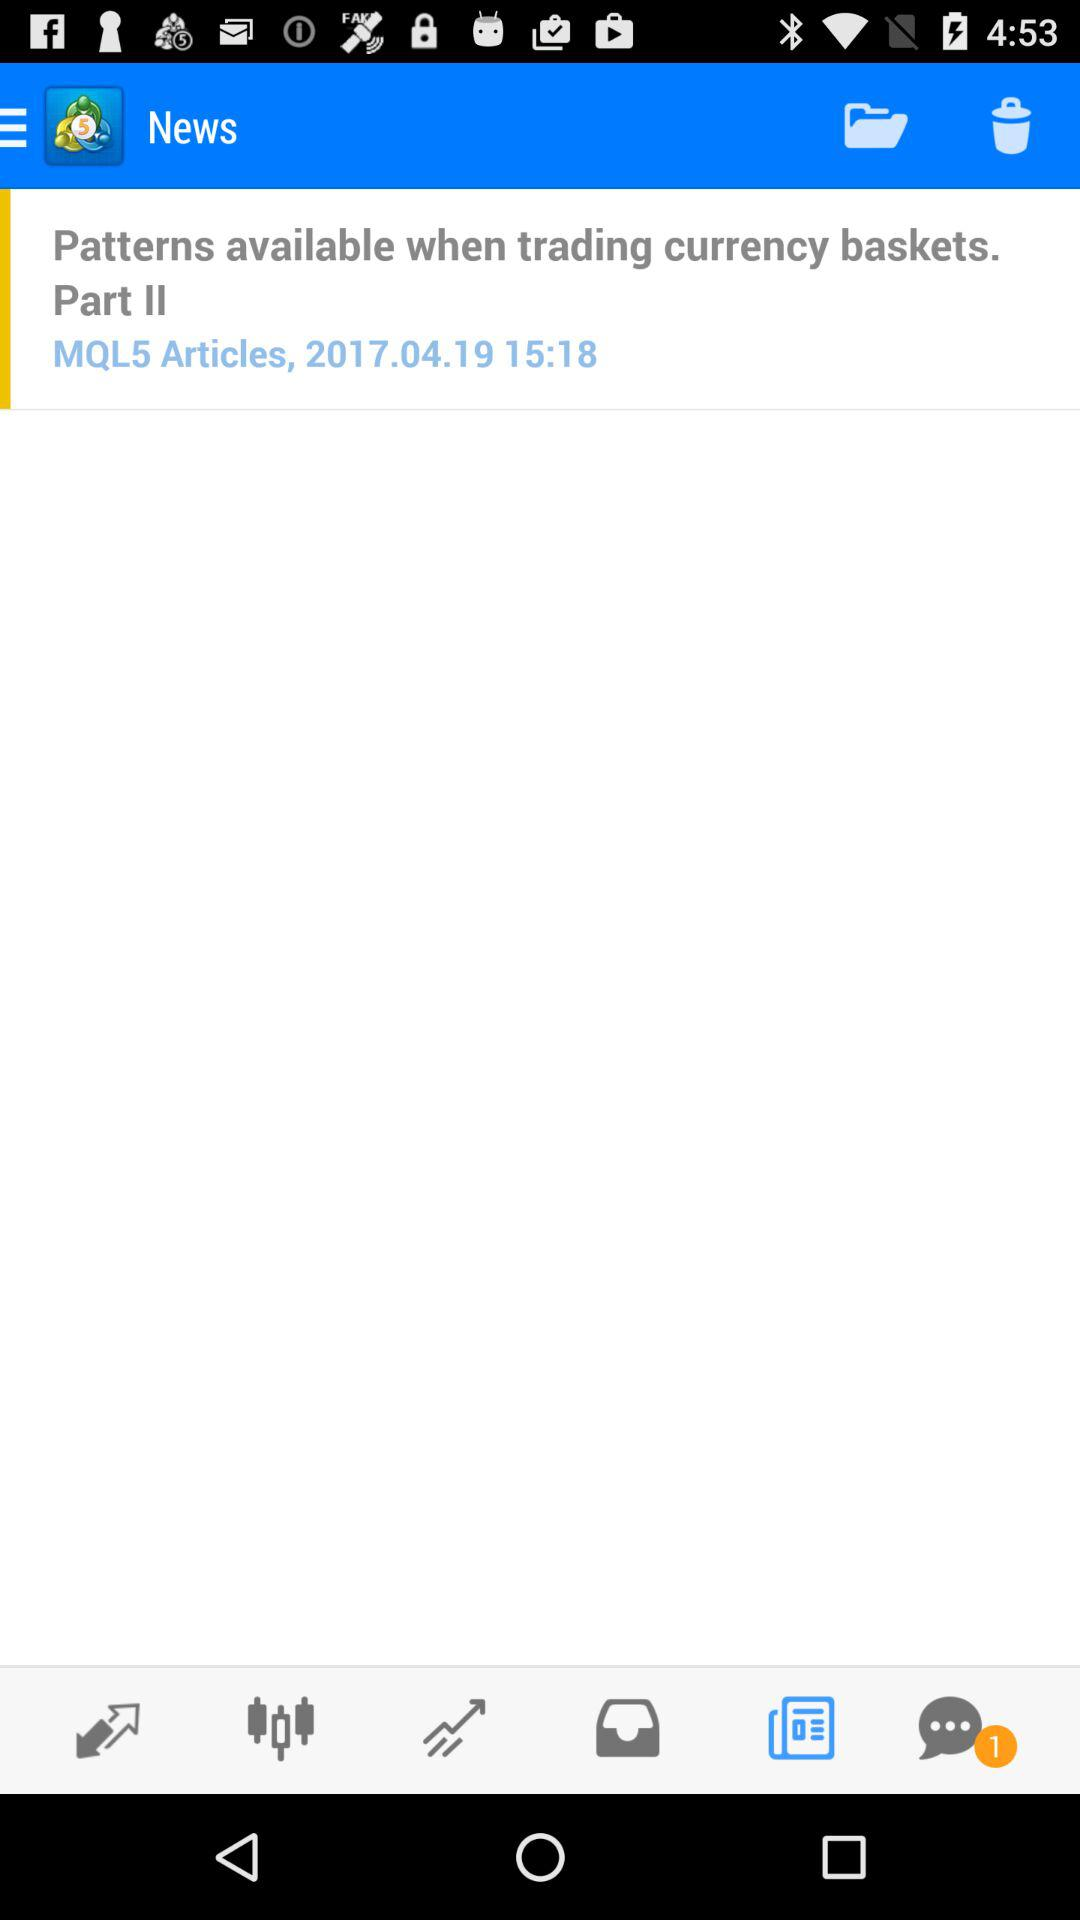What is the posted time of "Patterns available when trading currency baskets. Part II"? The posted time of "Patterns available when trading currency baskets. Part II" is 15:18. 